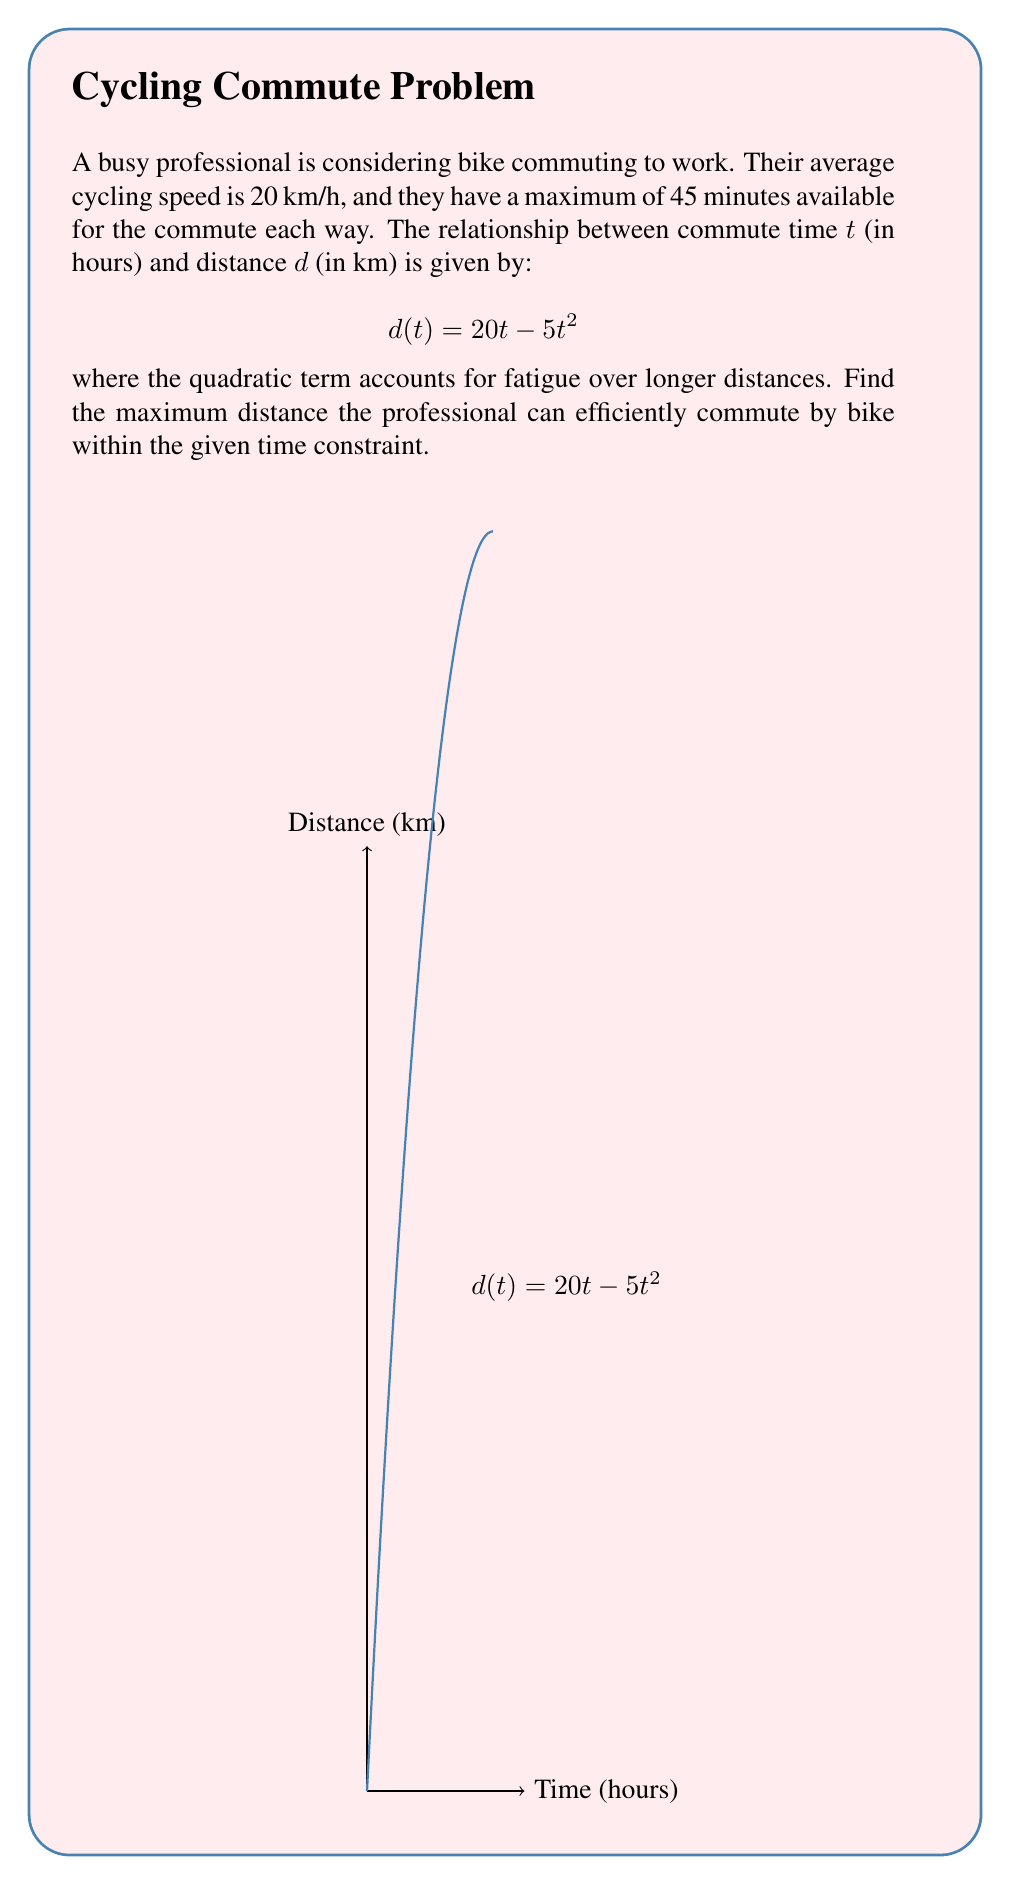Solve this math problem. Let's approach this step-by-step:

1) First, we need to convert the time constraint from minutes to hours:
   45 minutes = 0.75 hours

2) Now, we have a function $d(t) = 20t - 5t^2$ and we need to find its maximum value within the domain $0 \leq t \leq 0.75$.

3) To find the maximum, we can use differentiation. Let's find the derivative of $d(t)$:
   $$\frac{d}{dt}d(t) = 20 - 10t$$

4) Set the derivative to zero to find the critical point:
   $$20 - 10t = 0$$
   $$10t = 20$$
   $$t = 2$$

5) However, $t = 2$ is outside our domain of $0 \leq t \leq 0.75$. This means the maximum within our domain will occur at one of the endpoints.

6) Let's evaluate $d(t)$ at both endpoints:
   At $t = 0$: $d(0) = 20(0) - 5(0)^2 = 0$
   At $t = 0.75$: $d(0.75) = 20(0.75) - 5(0.75)^2 = 15 - 2.8125 = 12.1875$

7) Clearly, the maximum distance occurs at $t = 0.75$ hours (our time constraint).

Therefore, the maximum distance the professional can efficiently commute by bike within the 45-minute (0.75-hour) time constraint is 12.1875 km.
Answer: 12.1875 km 